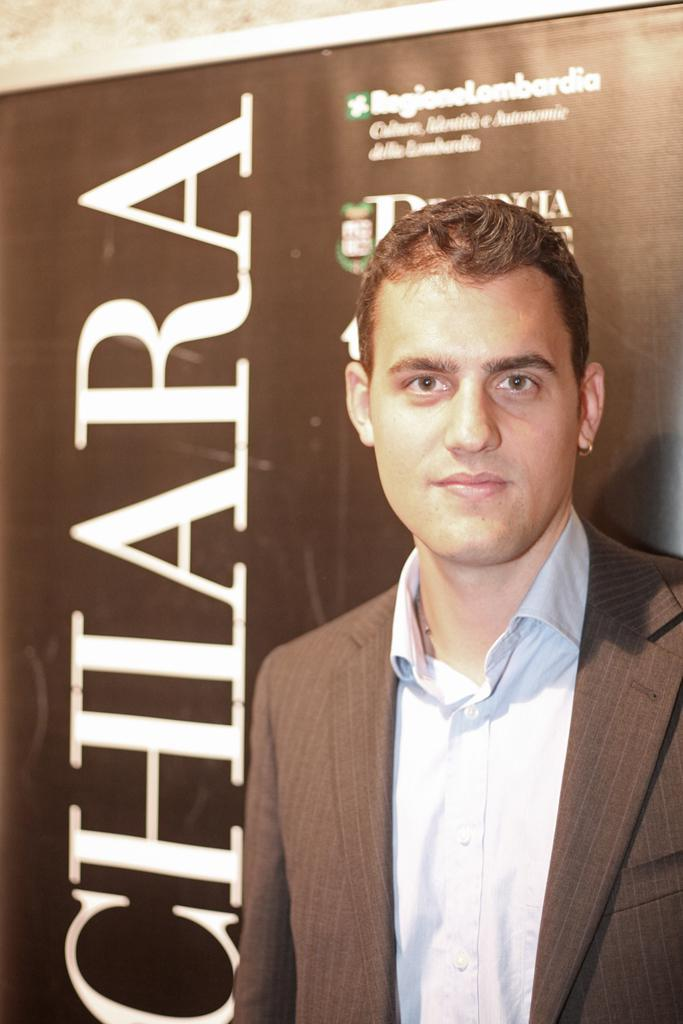Who is present in the image? There is a man in the image. Where is the man located in the image? The man is on the right side of the image. What is the man wearing in the image? The man is wearing a coat in the image. What can be seen in the background of the image? There is an advertising board in the background of the image. How many babies are present in the image? There are no babies present in the image. What direction is the man facing in the image? The provided facts do not specify the direction the man is facing. 